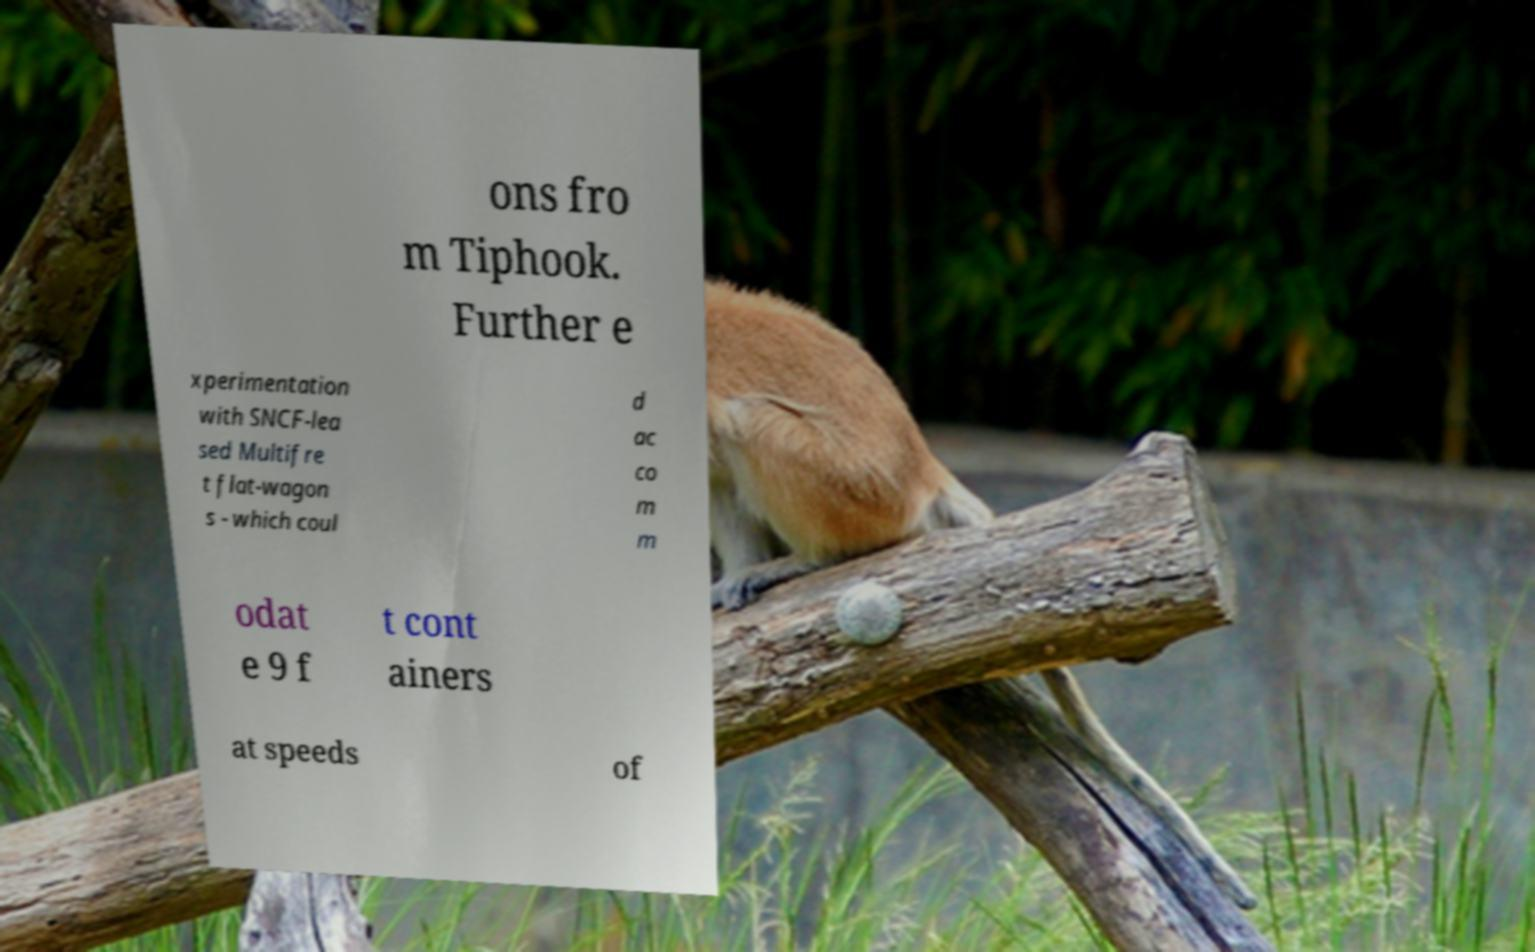There's text embedded in this image that I need extracted. Can you transcribe it verbatim? ons fro m Tiphook. Further e xperimentation with SNCF-lea sed Multifre t flat-wagon s - which coul d ac co m m odat e 9 f t cont ainers at speeds of 